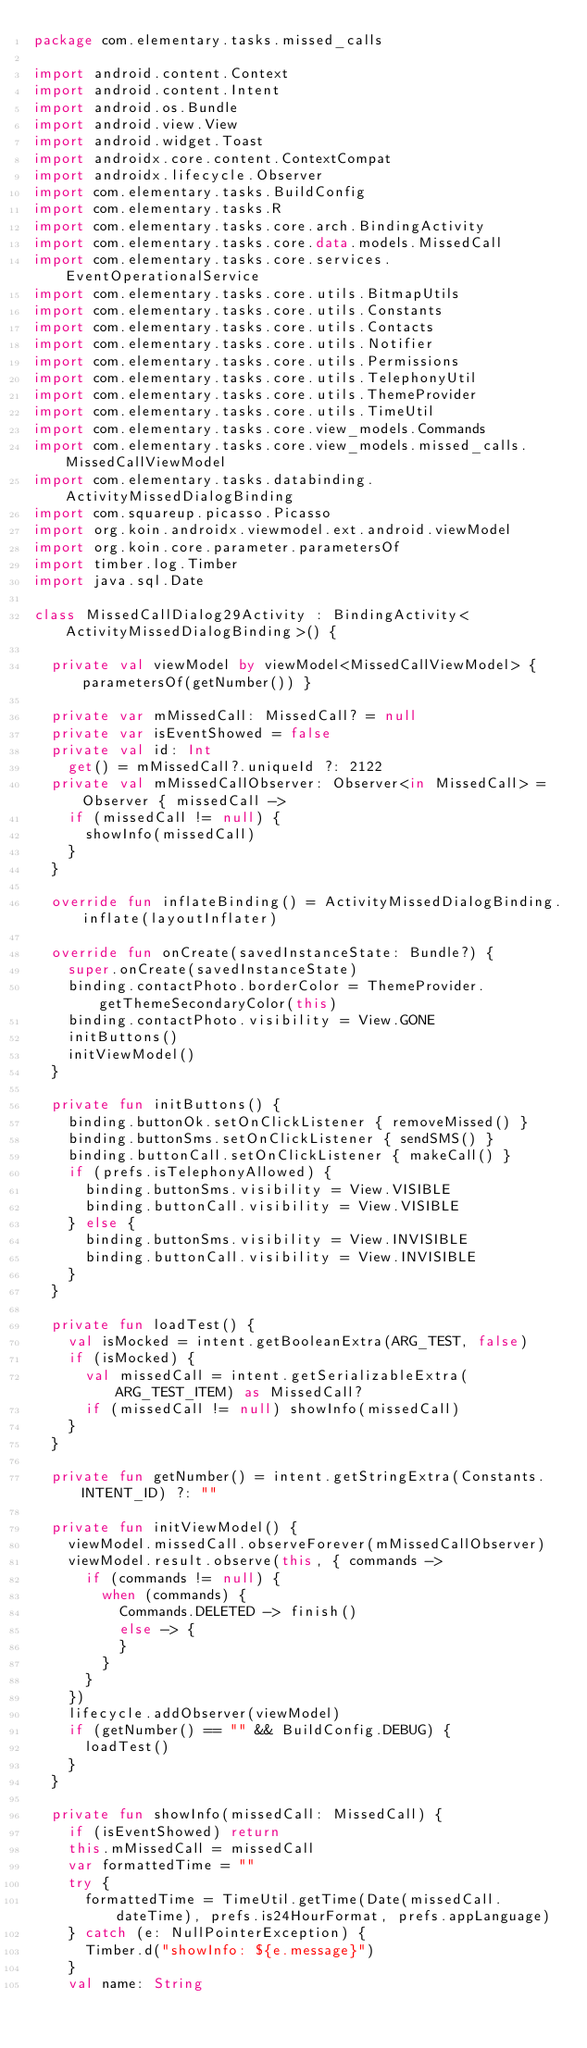Convert code to text. <code><loc_0><loc_0><loc_500><loc_500><_Kotlin_>package com.elementary.tasks.missed_calls

import android.content.Context
import android.content.Intent
import android.os.Bundle
import android.view.View
import android.widget.Toast
import androidx.core.content.ContextCompat
import androidx.lifecycle.Observer
import com.elementary.tasks.BuildConfig
import com.elementary.tasks.R
import com.elementary.tasks.core.arch.BindingActivity
import com.elementary.tasks.core.data.models.MissedCall
import com.elementary.tasks.core.services.EventOperationalService
import com.elementary.tasks.core.utils.BitmapUtils
import com.elementary.tasks.core.utils.Constants
import com.elementary.tasks.core.utils.Contacts
import com.elementary.tasks.core.utils.Notifier
import com.elementary.tasks.core.utils.Permissions
import com.elementary.tasks.core.utils.TelephonyUtil
import com.elementary.tasks.core.utils.ThemeProvider
import com.elementary.tasks.core.utils.TimeUtil
import com.elementary.tasks.core.view_models.Commands
import com.elementary.tasks.core.view_models.missed_calls.MissedCallViewModel
import com.elementary.tasks.databinding.ActivityMissedDialogBinding
import com.squareup.picasso.Picasso
import org.koin.androidx.viewmodel.ext.android.viewModel
import org.koin.core.parameter.parametersOf
import timber.log.Timber
import java.sql.Date

class MissedCallDialog29Activity : BindingActivity<ActivityMissedDialogBinding>() {

  private val viewModel by viewModel<MissedCallViewModel> { parametersOf(getNumber()) }

  private var mMissedCall: MissedCall? = null
  private var isEventShowed = false
  private val id: Int
    get() = mMissedCall?.uniqueId ?: 2122
  private val mMissedCallObserver: Observer<in MissedCall> = Observer { missedCall ->
    if (missedCall != null) {
      showInfo(missedCall)
    }
  }

  override fun inflateBinding() = ActivityMissedDialogBinding.inflate(layoutInflater)

  override fun onCreate(savedInstanceState: Bundle?) {
    super.onCreate(savedInstanceState)
    binding.contactPhoto.borderColor = ThemeProvider.getThemeSecondaryColor(this)
    binding.contactPhoto.visibility = View.GONE
    initButtons()
    initViewModel()
  }

  private fun initButtons() {
    binding.buttonOk.setOnClickListener { removeMissed() }
    binding.buttonSms.setOnClickListener { sendSMS() }
    binding.buttonCall.setOnClickListener { makeCall() }
    if (prefs.isTelephonyAllowed) {
      binding.buttonSms.visibility = View.VISIBLE
      binding.buttonCall.visibility = View.VISIBLE
    } else {
      binding.buttonSms.visibility = View.INVISIBLE
      binding.buttonCall.visibility = View.INVISIBLE
    }
  }

  private fun loadTest() {
    val isMocked = intent.getBooleanExtra(ARG_TEST, false)
    if (isMocked) {
      val missedCall = intent.getSerializableExtra(ARG_TEST_ITEM) as MissedCall?
      if (missedCall != null) showInfo(missedCall)
    }
  }

  private fun getNumber() = intent.getStringExtra(Constants.INTENT_ID) ?: ""

  private fun initViewModel() {
    viewModel.missedCall.observeForever(mMissedCallObserver)
    viewModel.result.observe(this, { commands ->
      if (commands != null) {
        when (commands) {
          Commands.DELETED -> finish()
          else -> {
          }
        }
      }
    })
    lifecycle.addObserver(viewModel)
    if (getNumber() == "" && BuildConfig.DEBUG) {
      loadTest()
    }
  }

  private fun showInfo(missedCall: MissedCall) {
    if (isEventShowed) return
    this.mMissedCall = missedCall
    var formattedTime = ""
    try {
      formattedTime = TimeUtil.getTime(Date(missedCall.dateTime), prefs.is24HourFormat, prefs.appLanguage)
    } catch (e: NullPointerException) {
      Timber.d("showInfo: ${e.message}")
    }
    val name: String</code> 